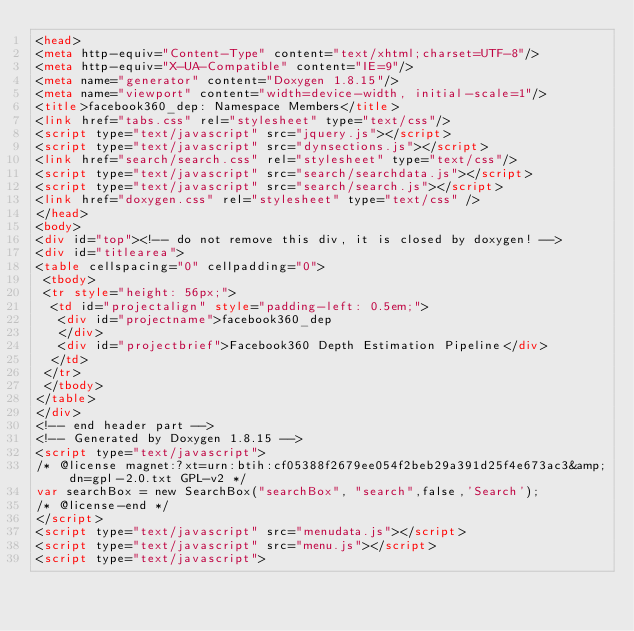Convert code to text. <code><loc_0><loc_0><loc_500><loc_500><_HTML_><head>
<meta http-equiv="Content-Type" content="text/xhtml;charset=UTF-8"/>
<meta http-equiv="X-UA-Compatible" content="IE=9"/>
<meta name="generator" content="Doxygen 1.8.15"/>
<meta name="viewport" content="width=device-width, initial-scale=1"/>
<title>facebook360_dep: Namespace Members</title>
<link href="tabs.css" rel="stylesheet" type="text/css"/>
<script type="text/javascript" src="jquery.js"></script>
<script type="text/javascript" src="dynsections.js"></script>
<link href="search/search.css" rel="stylesheet" type="text/css"/>
<script type="text/javascript" src="search/searchdata.js"></script>
<script type="text/javascript" src="search/search.js"></script>
<link href="doxygen.css" rel="stylesheet" type="text/css" />
</head>
<body>
<div id="top"><!-- do not remove this div, it is closed by doxygen! -->
<div id="titlearea">
<table cellspacing="0" cellpadding="0">
 <tbody>
 <tr style="height: 56px;">
  <td id="projectalign" style="padding-left: 0.5em;">
   <div id="projectname">facebook360_dep
   </div>
   <div id="projectbrief">Facebook360 Depth Estimation Pipeline</div>
  </td>
 </tr>
 </tbody>
</table>
</div>
<!-- end header part -->
<!-- Generated by Doxygen 1.8.15 -->
<script type="text/javascript">
/* @license magnet:?xt=urn:btih:cf05388f2679ee054f2beb29a391d25f4e673ac3&amp;dn=gpl-2.0.txt GPL-v2 */
var searchBox = new SearchBox("searchBox", "search",false,'Search');
/* @license-end */
</script>
<script type="text/javascript" src="menudata.js"></script>
<script type="text/javascript" src="menu.js"></script>
<script type="text/javascript"></code> 